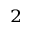Convert formula to latex. <formula><loc_0><loc_0><loc_500><loc_500>^ { 2 }</formula> 